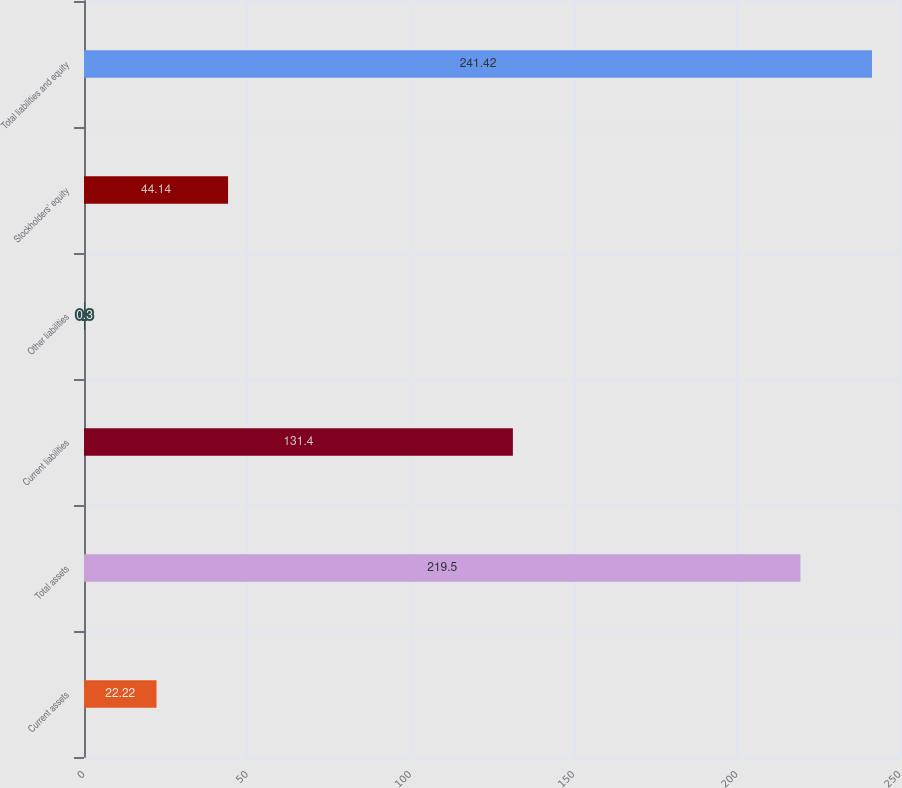Convert chart to OTSL. <chart><loc_0><loc_0><loc_500><loc_500><bar_chart><fcel>Current assets<fcel>Total assets<fcel>Current liabilities<fcel>Other liabilities<fcel>Stockholders' equity<fcel>Total liabilities and equity<nl><fcel>22.22<fcel>219.5<fcel>131.4<fcel>0.3<fcel>44.14<fcel>241.42<nl></chart> 